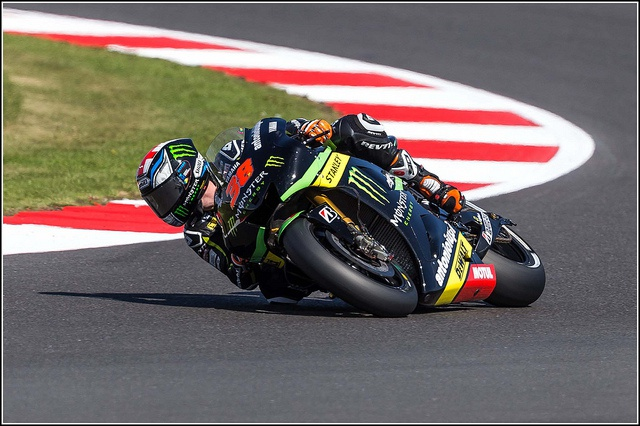Describe the objects in this image and their specific colors. I can see motorcycle in black, gray, navy, and lightgray tones and people in black, gray, lightgray, and navy tones in this image. 